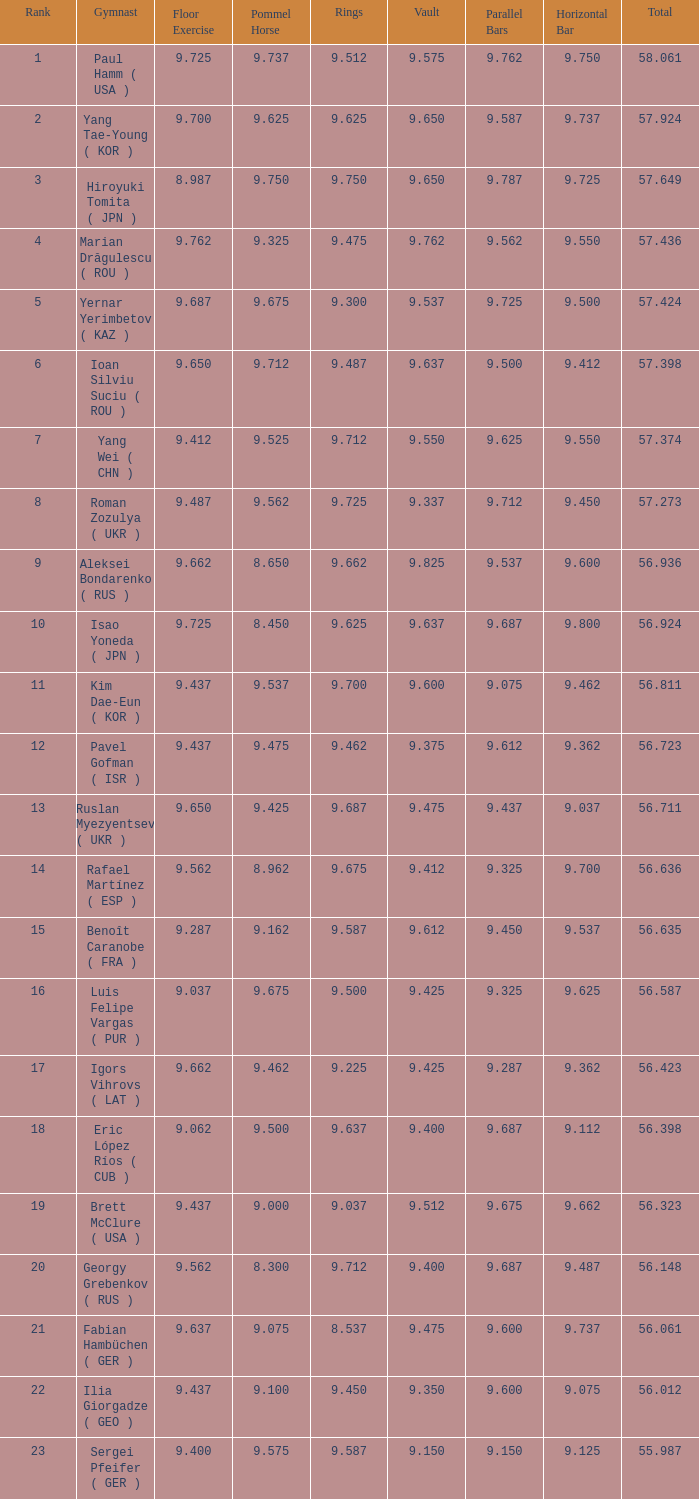What is the total score when the score for floor exercise was 9.287? 56.635. 